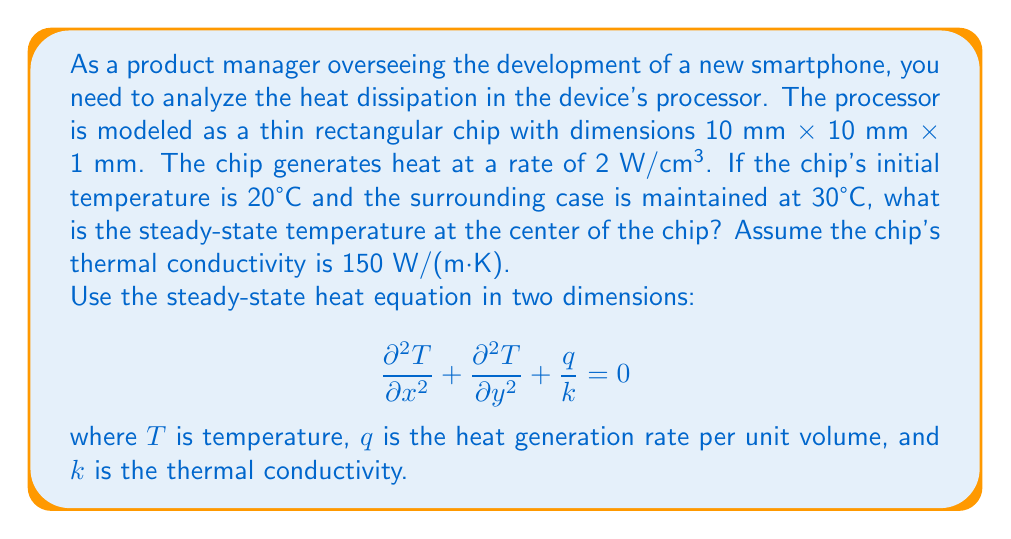Solve this math problem. Let's approach this problem step-by-step:

1) First, we need to set up the heat equation for our specific case. The steady-state 2D heat equation with heat generation is:

   $$\frac{\partial^2 T}{\partial x^2} + \frac{\partial^2 T}{\partial y^2} + \frac{q}{k} = 0$$

2) We're given:
   - Heat generation rate: $q = 2 \text{ W/cm³} = 2 \times 10^6 \text{ W/m³}$
   - Thermal conductivity: $k = 150 \text{ W/(m·K)}$

3) Substituting these values:

   $$\frac{\partial^2 T}{\partial x^2} + \frac{\partial^2 T}{\partial y^2} + \frac{2 \times 10^6}{150} = 0$$

4) For a square chip with uniform heat generation, the temperature distribution will be symmetrical, with the highest temperature at the center. At steady-state, the temperature at any point can be approximated by:

   $$T(x,y) = T_c + \frac{q}{2k}(L^2 - x^2 - y^2)$$

   where $T_c$ is the case temperature, $L$ is half the chip's width, and $(x,y)$ are coordinates with the origin at the chip's center.

5) At the center, $x = y = 0$, so:

   $$T(0,0) = T_c + \frac{q}{2k}L^2$$

6) Substituting the values:
   - $T_c = 30°C$
   - $q = 2 \times 10^6 \text{ W/m³}$
   - $k = 150 \text{ W/(m·K)}$
   - $L = 5 \text{ mm} = 0.005 \text{ m}$

   $$T(0,0) = 30 + \frac{2 \times 10^6}{2 \times 150}(0.005)^2$$

7) Calculating:

   $$T(0,0) = 30 + 166.67 = 196.67°C$$

Therefore, the steady-state temperature at the center of the chip is approximately 196.67°C.
Answer: 196.67°C 